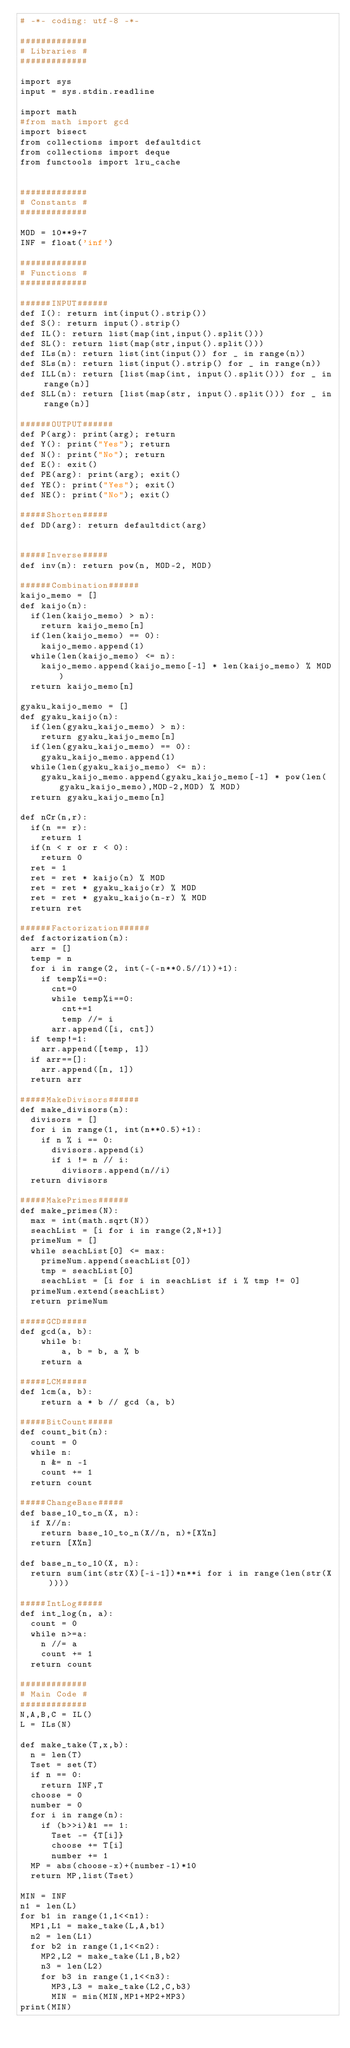<code> <loc_0><loc_0><loc_500><loc_500><_Python_># -*- coding: utf-8 -*-

#############
# Libraries #
#############

import sys
input = sys.stdin.readline

import math
#from math import gcd
import bisect
from collections import defaultdict
from collections import deque
from functools import lru_cache


#############
# Constants #
#############

MOD = 10**9+7
INF = float('inf')

#############
# Functions #
#############

######INPUT######
def I(): return int(input().strip())
def S(): return input().strip()
def IL(): return list(map(int,input().split()))
def SL(): return list(map(str,input().split()))
def ILs(n): return list(int(input()) for _ in range(n))
def SLs(n): return list(input().strip() for _ in range(n))
def ILL(n): return [list(map(int, input().split())) for _ in range(n)]
def SLL(n): return [list(map(str, input().split())) for _ in range(n)]

######OUTPUT######
def P(arg): print(arg); return
def Y(): print("Yes"); return
def N(): print("No"); return
def E(): exit()
def PE(arg): print(arg); exit()
def YE(): print("Yes"); exit()
def NE(): print("No"); exit()

#####Shorten#####
def DD(arg): return defaultdict(arg)


#####Inverse#####
def inv(n): return pow(n, MOD-2, MOD)

######Combination######
kaijo_memo = []
def kaijo(n):
  if(len(kaijo_memo) > n):
    return kaijo_memo[n]
  if(len(kaijo_memo) == 0):
    kaijo_memo.append(1)
  while(len(kaijo_memo) <= n):
    kaijo_memo.append(kaijo_memo[-1] * len(kaijo_memo) % MOD)
  return kaijo_memo[n]

gyaku_kaijo_memo = []
def gyaku_kaijo(n):
  if(len(gyaku_kaijo_memo) > n):
    return gyaku_kaijo_memo[n]
  if(len(gyaku_kaijo_memo) == 0):
    gyaku_kaijo_memo.append(1)
  while(len(gyaku_kaijo_memo) <= n):
    gyaku_kaijo_memo.append(gyaku_kaijo_memo[-1] * pow(len(gyaku_kaijo_memo),MOD-2,MOD) % MOD)
  return gyaku_kaijo_memo[n]

def nCr(n,r):
  if(n == r):
    return 1
  if(n < r or r < 0):
    return 0
  ret = 1
  ret = ret * kaijo(n) % MOD
  ret = ret * gyaku_kaijo(r) % MOD
  ret = ret * gyaku_kaijo(n-r) % MOD
  return ret

######Factorization######
def factorization(n):
  arr = []
  temp = n
  for i in range(2, int(-(-n**0.5//1))+1):
    if temp%i==0:
      cnt=0
      while temp%i==0: 
        cnt+=1 
        temp //= i
      arr.append([i, cnt])
  if temp!=1:
    arr.append([temp, 1])
  if arr==[]:
    arr.append([n, 1])
  return arr

#####MakeDivisors######
def make_divisors(n):
  divisors = []
  for i in range(1, int(n**0.5)+1):
    if n % i == 0:
      divisors.append(i)
      if i != n // i: 
        divisors.append(n//i)
  return divisors

#####MakePrimes######
def make_primes(N):
  max = int(math.sqrt(N))
  seachList = [i for i in range(2,N+1)]
  primeNum = []
  while seachList[0] <= max:
    primeNum.append(seachList[0])
    tmp = seachList[0]
    seachList = [i for i in seachList if i % tmp != 0]
  primeNum.extend(seachList)
  return primeNum

#####GCD#####
def gcd(a, b):
    while b:
        a, b = b, a % b
    return a

#####LCM#####
def lcm(a, b):
    return a * b // gcd (a, b)

#####BitCount#####
def count_bit(n):
  count = 0
  while n:
    n &= n -1
    count += 1
  return count

#####ChangeBase#####
def base_10_to_n(X, n):
  if X//n:
    return base_10_to_n(X//n, n)+[X%n]
  return [X%n]

def base_n_to_10(X, n):
  return sum(int(str(X)[-i-1])*n**i for i in range(len(str(X))))

#####IntLog#####
def int_log(n, a):
  count = 0
  while n>=a:
    n //= a
    count += 1
  return count

#############
# Main Code #
#############
N,A,B,C = IL()
L = ILs(N)

def make_take(T,x,b):
  n = len(T)
  Tset = set(T)
  if n == 0:
    return INF,T
  choose = 0
  number = 0
  for i in range(n):
    if (b>>i)&1 == 1:
      Tset -= {T[i]}
      choose += T[i]
      number += 1
  MP = abs(choose-x)+(number-1)*10
  return MP,list(Tset)

MIN = INF
n1 = len(L)
for b1 in range(1,1<<n1):
  MP1,L1 = make_take(L,A,b1)
  n2 = len(L1)
  for b2 in range(1,1<<n2):
    MP2,L2 = make_take(L1,B,b2)
    n3 = len(L2)
    for b3 in range(1,1<<n3):
      MP3,L3 = make_take(L2,C,b3)
      MIN = min(MIN,MP1+MP2+MP3)
print(MIN)</code> 